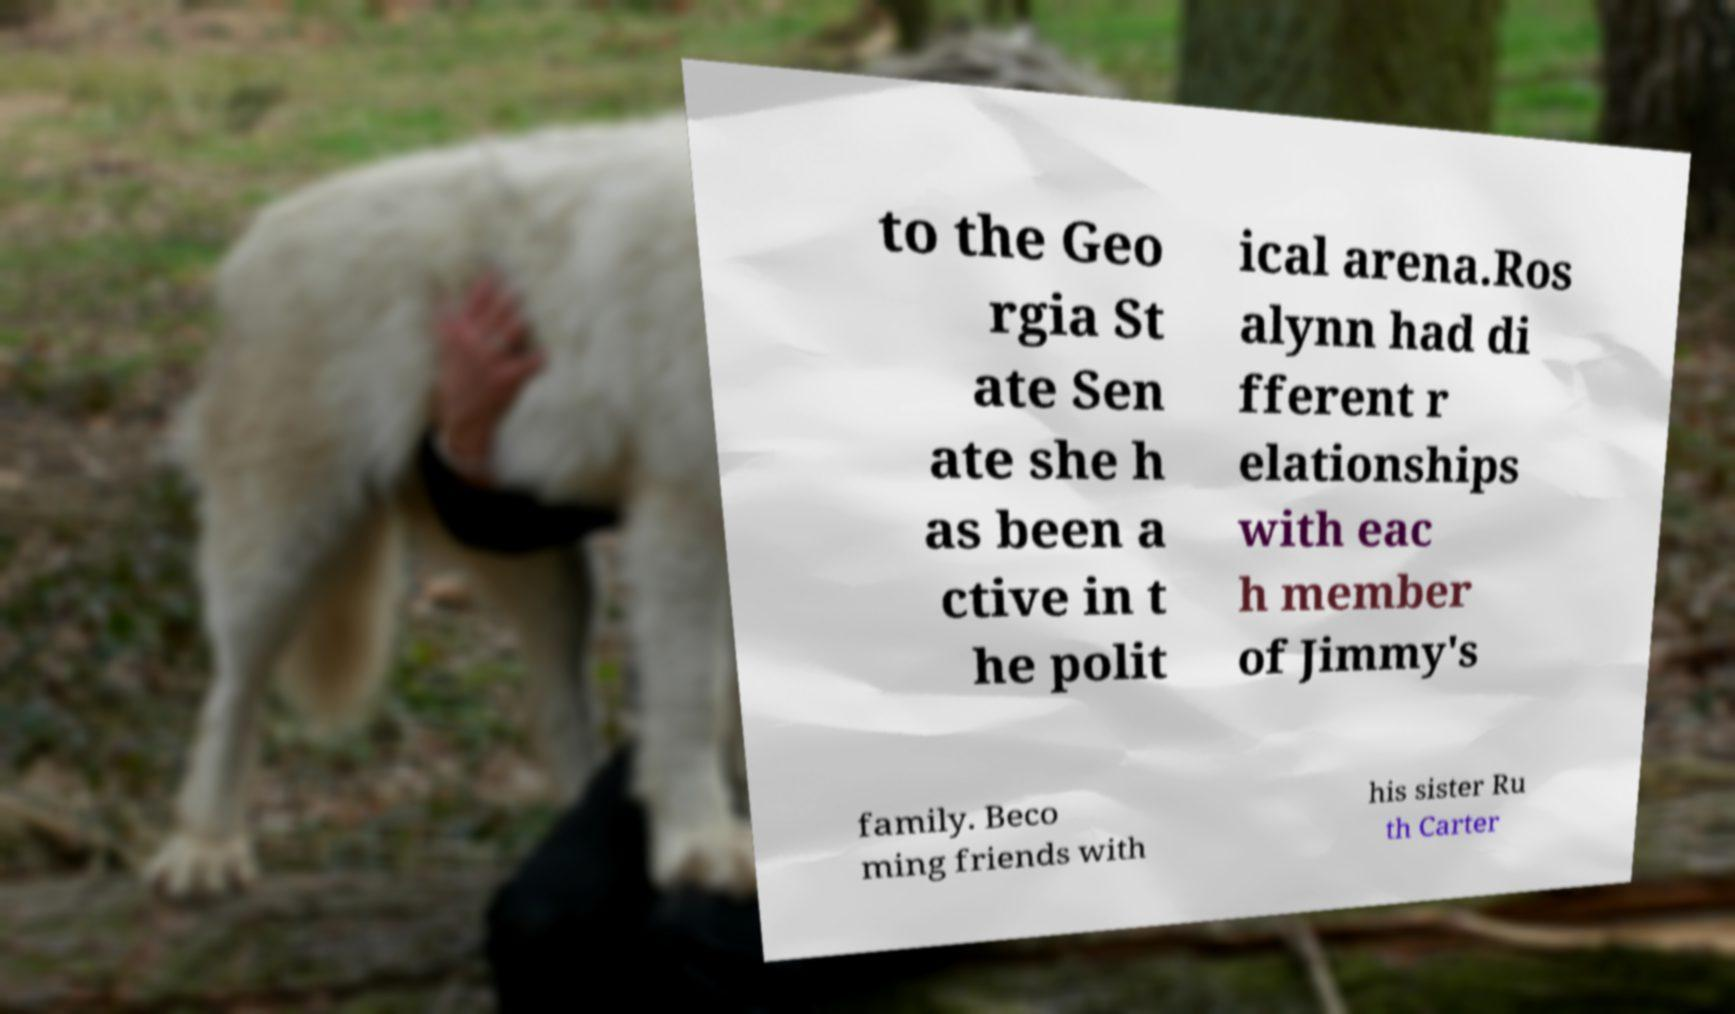I need the written content from this picture converted into text. Can you do that? to the Geo rgia St ate Sen ate she h as been a ctive in t he polit ical arena.Ros alynn had di fferent r elationships with eac h member of Jimmy's family. Beco ming friends with his sister Ru th Carter 